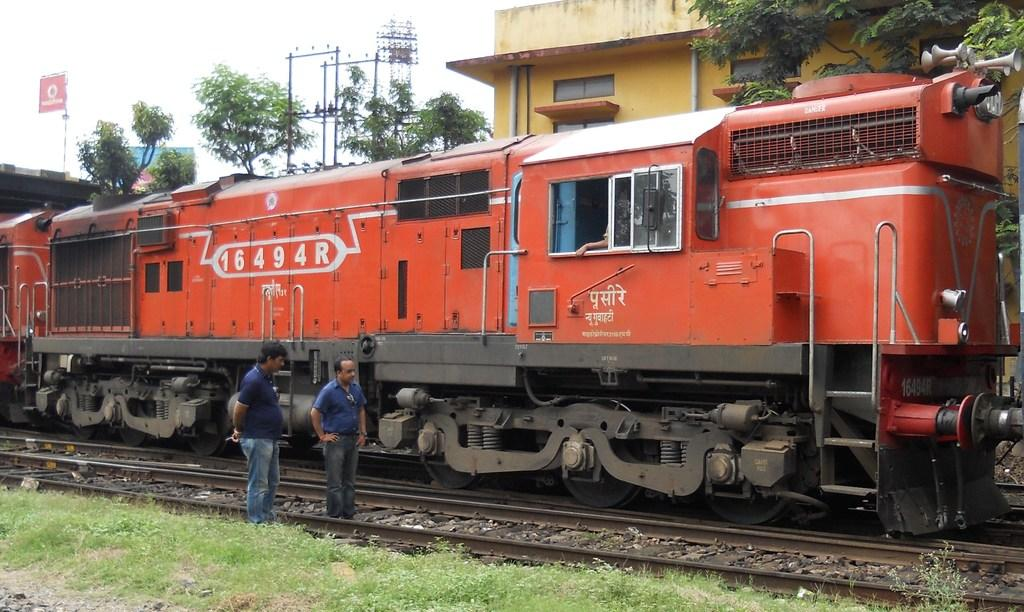<image>
Describe the image concisely. the numbers 1649 on the side of a train 